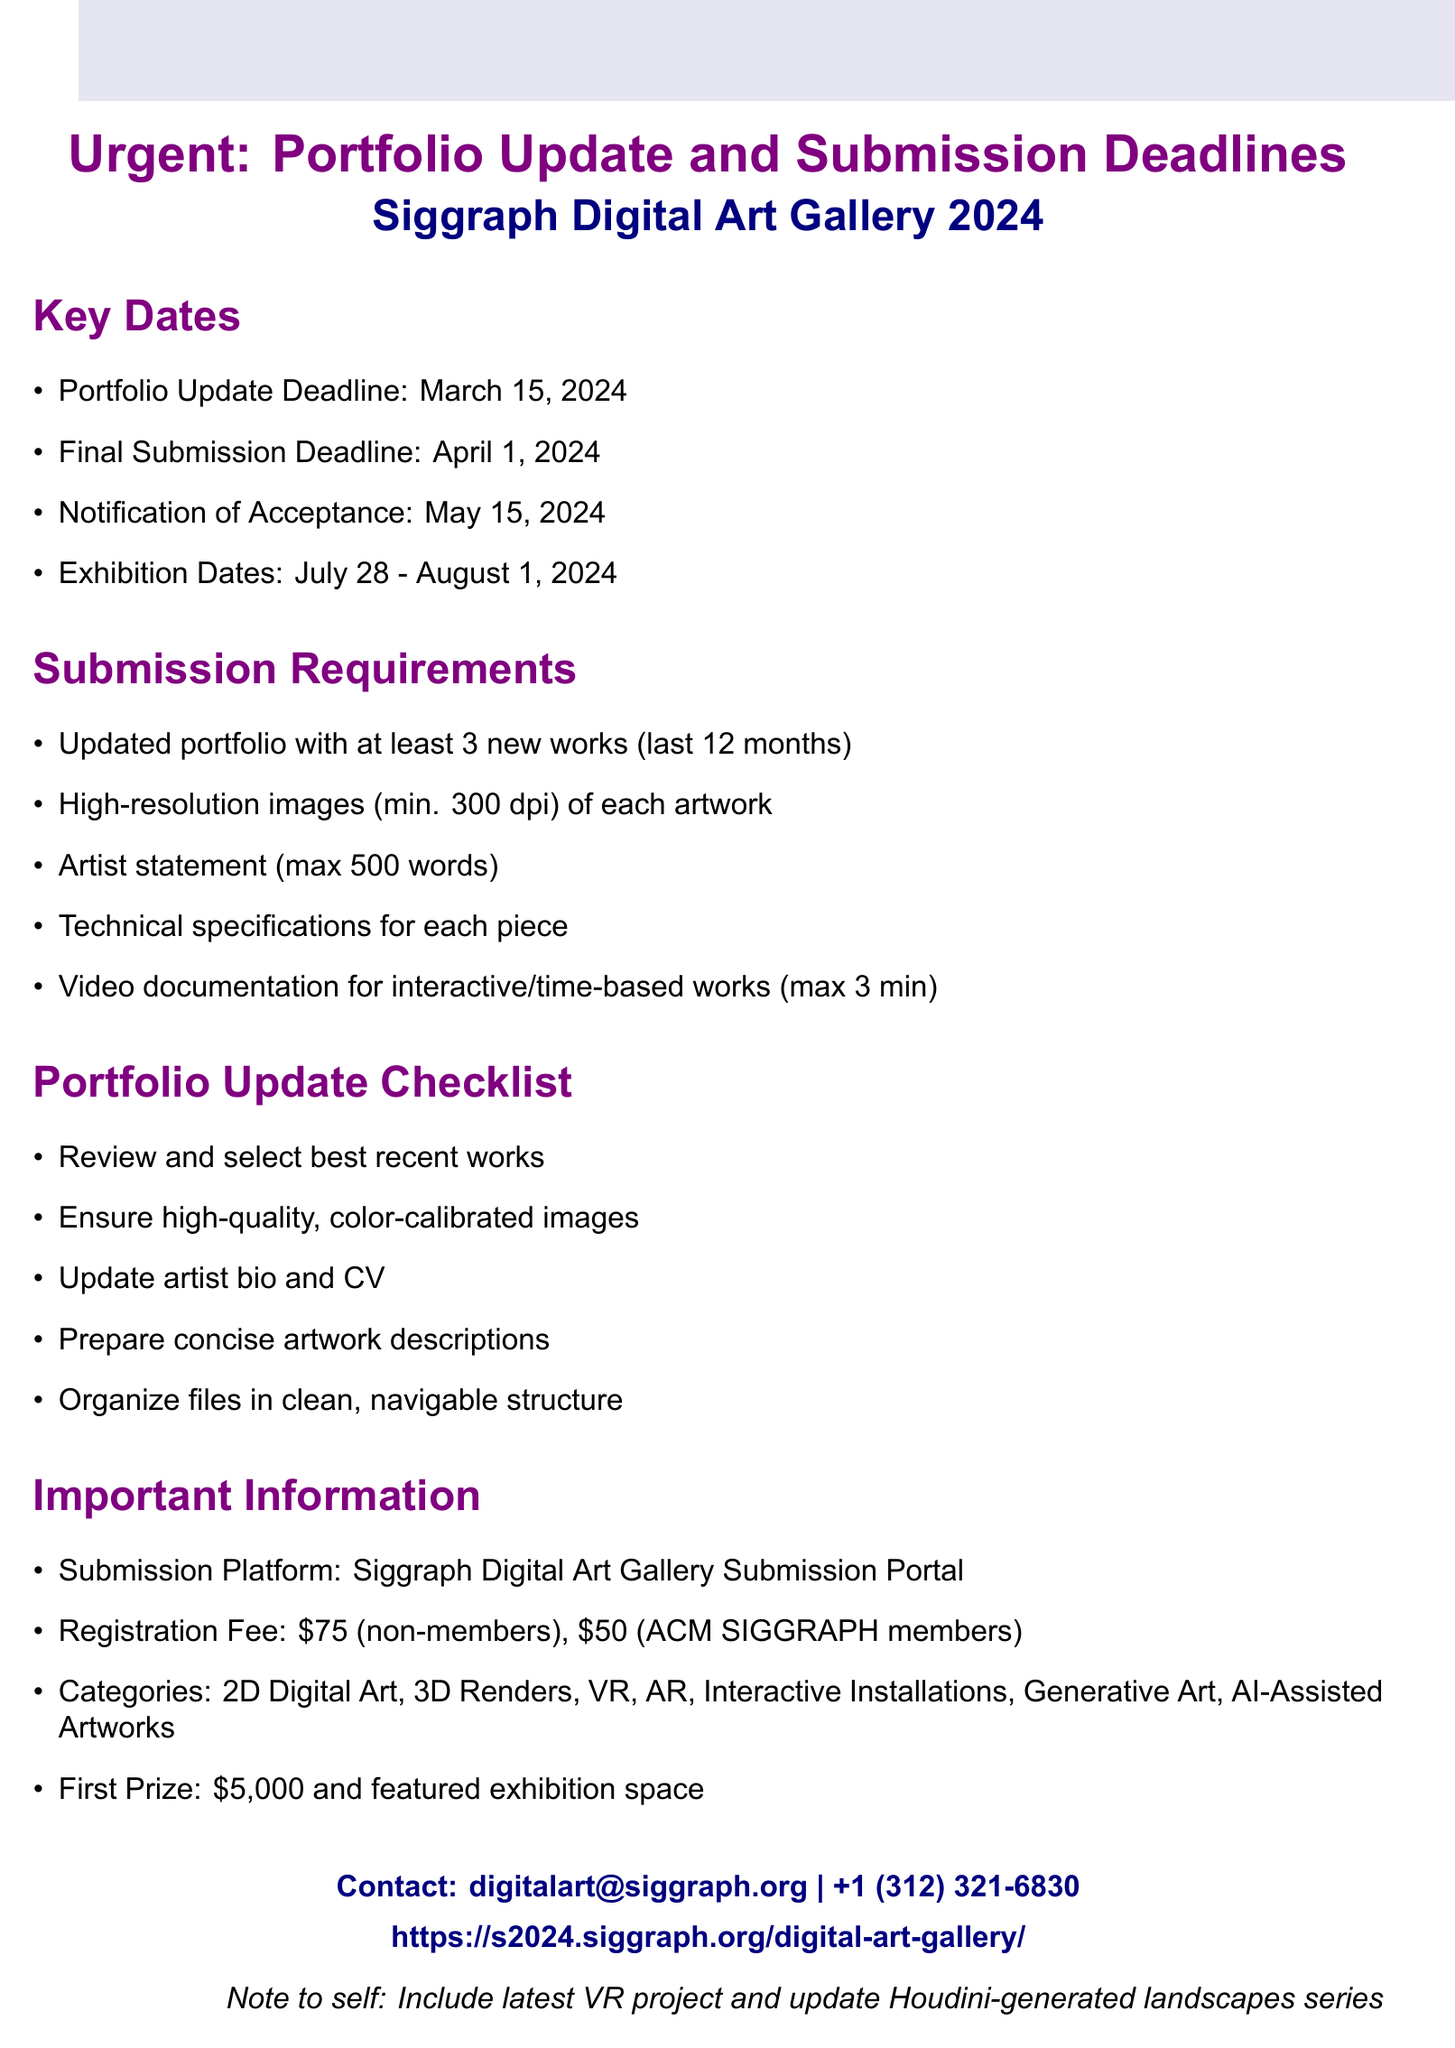What is the portfolio update deadline? The portfolio update deadline is a specific date mentioned in the document.
Answer: March 15, 2024 What is the registration fee for non-members? The registration fee for non-members is explicitly stated in the document.
Answer: $75 How many new works are required for the updated portfolio? The document specifies the minimum number of new works that should be included in the portfolio.
Answer: 3 When will the notification of acceptance be sent? The notification date is clearly listed in the key dates section of the document.
Answer: May 15, 2024 What prize does the first place winner receive? The document details the qualifications and prizes for the competition.
Answer: $5,000 and featured exhibition space What is the submission platform for the competition? This specific information is provided in the important information section of the document.
Answer: Siggraph Digital Art Gallery Submission Portal What should be included in the artist statement? The document outlines the requirements for the artist statement.
Answer: max 500 words What resources are available for portfolio reviews? The document mentions additional services available for artists.
Answer: Portfolio review services available through the Siggraph website Which category includes interactive works? The categories list indicates where interactive art fits.
Answer: Interactive Installations 